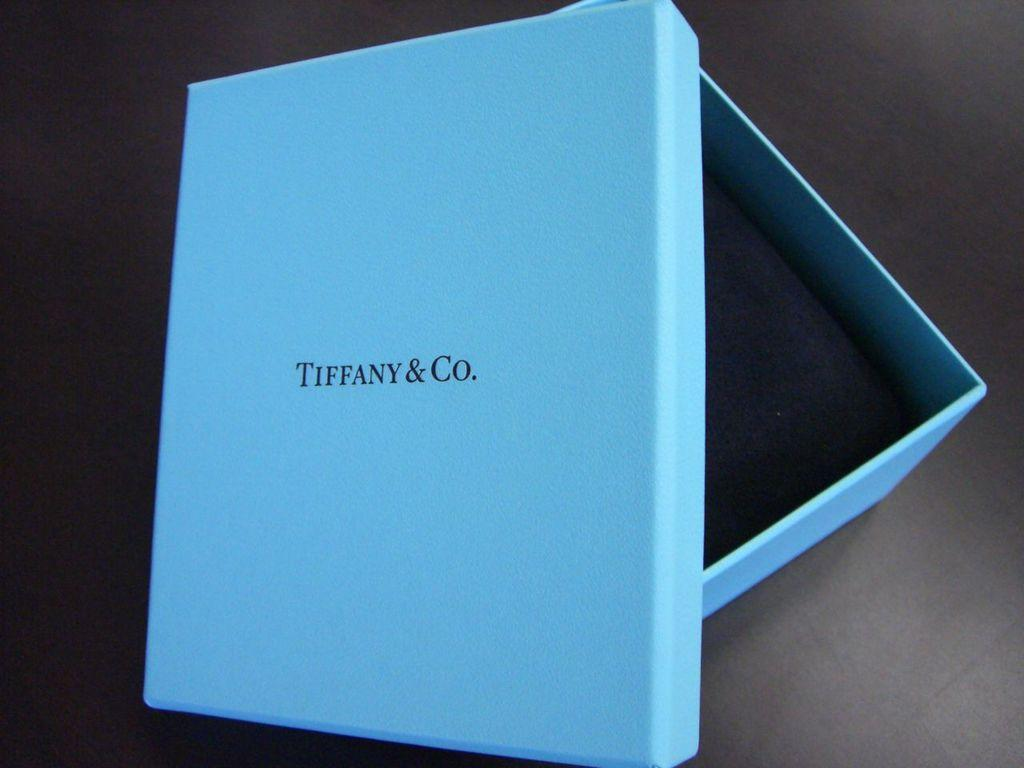<image>
Share a concise interpretation of the image provided. A light blue tiffany and co box sits open. 